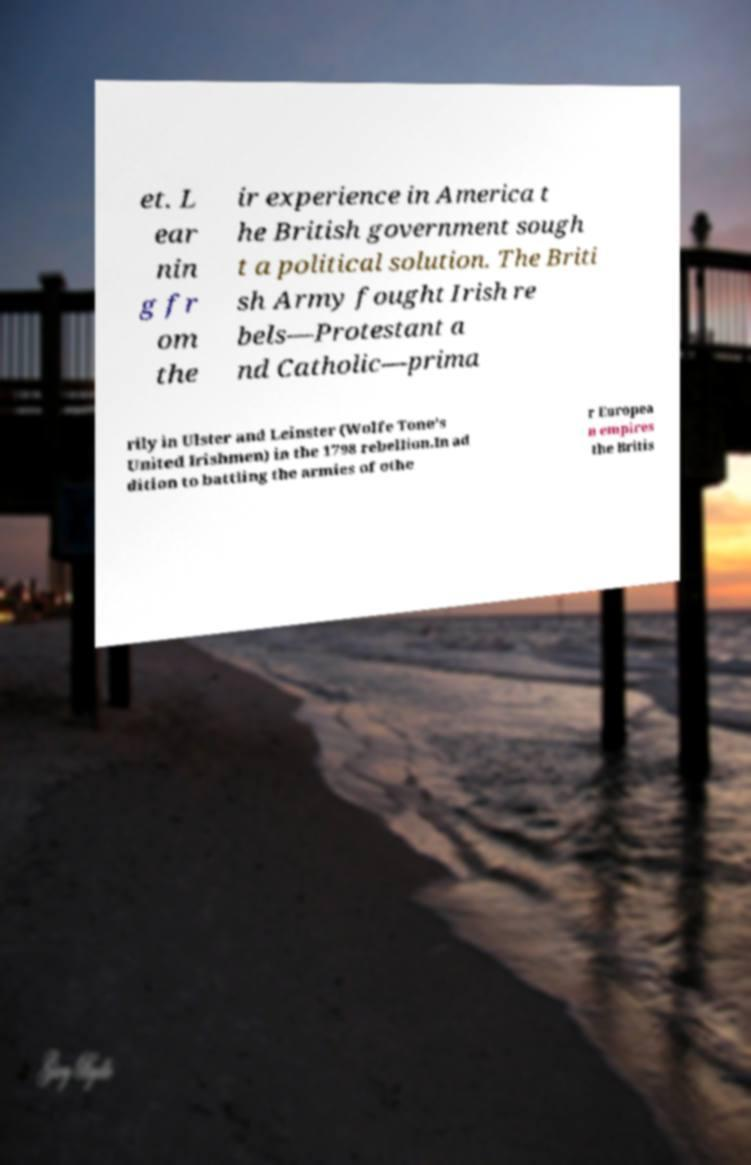Please read and relay the text visible in this image. What does it say? et. L ear nin g fr om the ir experience in America t he British government sough t a political solution. The Briti sh Army fought Irish re bels—Protestant a nd Catholic—prima rily in Ulster and Leinster (Wolfe Tone's United Irishmen) in the 1798 rebellion.In ad dition to battling the armies of othe r Europea n empires the Britis 